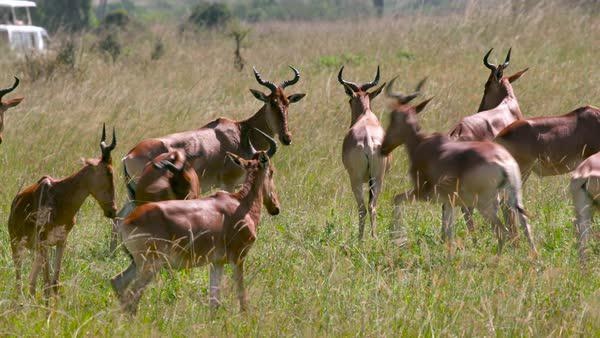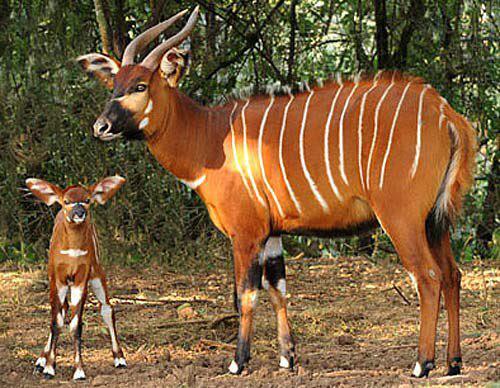The first image is the image on the left, the second image is the image on the right. Evaluate the accuracy of this statement regarding the images: "The horned animals in one image are all standing with their rears showing.". Is it true? Answer yes or no. No. 